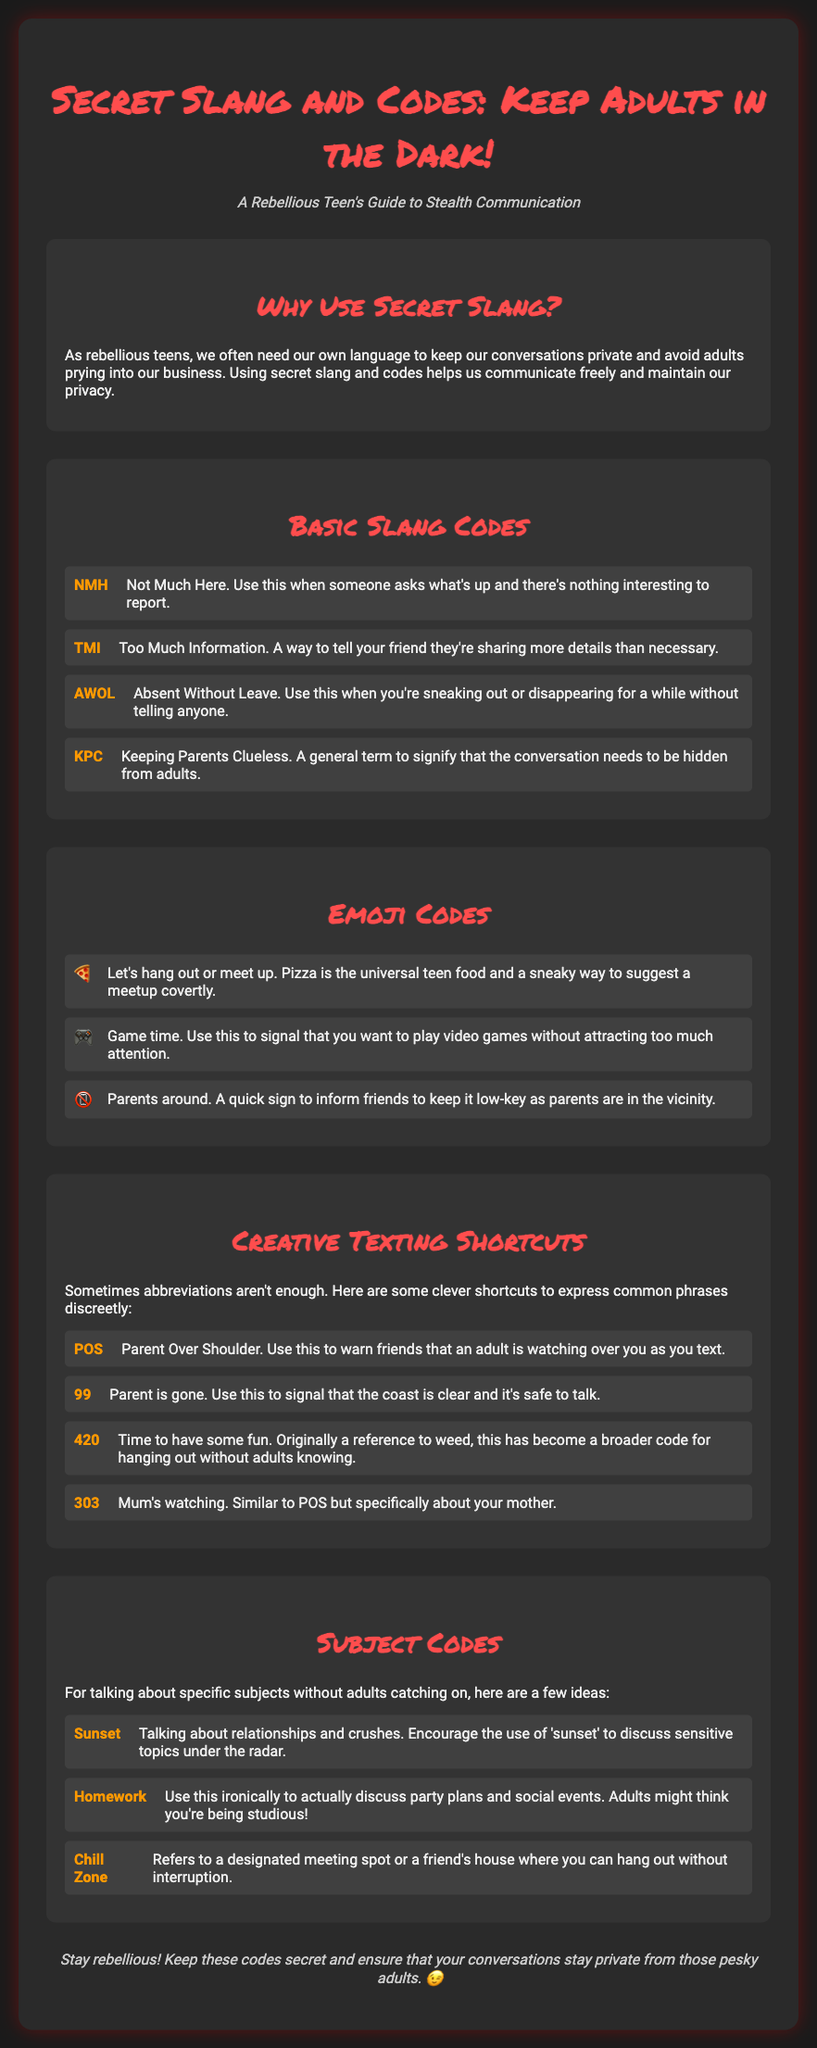What is the title of the document? The title of the document is given in the heading of the webpage.
Answer: Secret Slang and Codes: Keep Adults in the Dark! What does KPC stand for? KPC is one of the slang codes listed in the document, which signifies a need to hide the conversation from adults.
Answer: Keeping Parents Clueless What emoji represents "game time"? The document provides a specific emoji to signify this phrase.
Answer: 🎮 What is the meaning of 99 in this context? 99 is another abbreviation mentioned in the document, which indicates a certain situation regarding parents.
Answer: Parent is gone What is a synonym for the term "sunset" as used in the document? The term "sunset" is used as a code to refer to a particular subject that is sensitive.
Answer: Relationships and crushes What is the purpose of this document? The overall goal of the document is explained in the introductory section.
Answer: Stealth communication What is the style of the main title? The document describes how the title is visually presented.
Answer: Bold and colorful How many sections are in the document? The document outlines different aspects of secret slang and codes, indicating distinct topics covered.
Answer: Five 